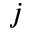<formula> <loc_0><loc_0><loc_500><loc_500>j</formula> 